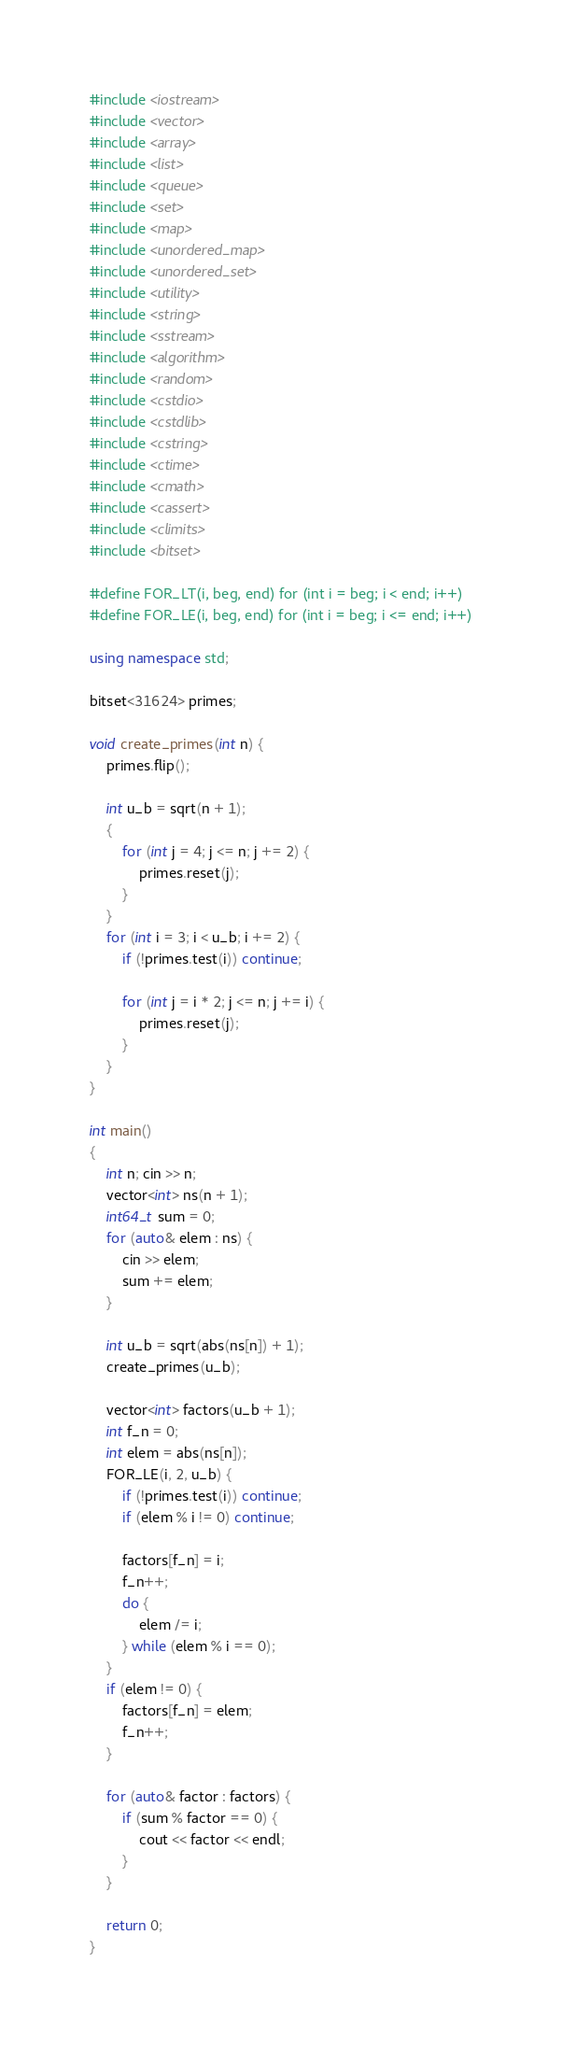<code> <loc_0><loc_0><loc_500><loc_500><_C++_>#include <iostream>
#include <vector>
#include <array>
#include <list>
#include <queue>
#include <set>
#include <map>
#include <unordered_map>
#include <unordered_set>
#include <utility>
#include <string>
#include <sstream>
#include <algorithm>
#include <random>
#include <cstdio>
#include <cstdlib>
#include <cstring>
#include <ctime>
#include <cmath>
#include <cassert>
#include <climits>
#include <bitset>

#define FOR_LT(i, beg, end) for (int i = beg; i < end; i++)
#define FOR_LE(i, beg, end) for (int i = beg; i <= end; i++)

using namespace std;

bitset<31624> primes;

void create_primes(int n) {
	primes.flip();

	int u_b = sqrt(n + 1);
	{
		for (int j = 4; j <= n; j += 2) {
			primes.reset(j);
		}
	}
	for (int i = 3; i < u_b; i += 2) {
		if (!primes.test(i)) continue;

		for (int j = i * 2; j <= n; j += i) {
			primes.reset(j);
		}
	}
}

int main()
{
	int n; cin >> n;
	vector<int> ns(n + 1);
	int64_t sum = 0;
	for (auto& elem : ns) {
		cin >> elem;
		sum += elem;
	}

	int u_b = sqrt(abs(ns[n]) + 1);
	create_primes(u_b);

	vector<int> factors(u_b + 1);
	int f_n = 0;
	int elem = abs(ns[n]);
	FOR_LE(i, 2, u_b) {
		if (!primes.test(i)) continue;
		if (elem % i != 0) continue;

		factors[f_n] = i;
		f_n++;
		do {
			elem /= i;
		} while (elem % i == 0);
	}
	if (elem != 0) {
		factors[f_n] = elem;
		f_n++;
	}

	for (auto& factor : factors) {
		if (sum % factor == 0) {
			cout << factor << endl;
		}
	}

	return 0;
}</code> 